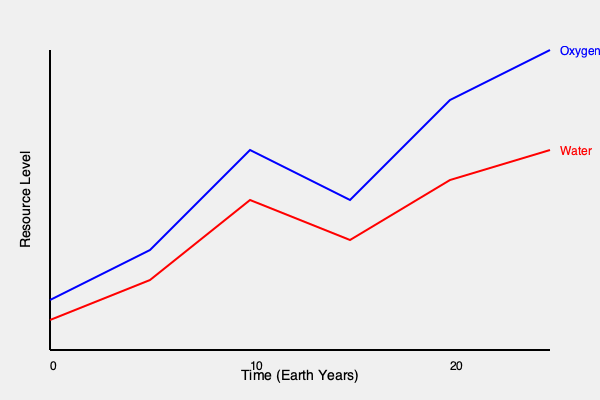In a futuristic space exploration mission, you're tasked with analyzing resource consumption trends. The graph shows oxygen and water levels over a 20-year period. What is the approximate ratio of the rate of oxygen depletion to water depletion between years 10 and 20? To solve this problem, we need to follow these steps:

1. Identify the data points for oxygen and water at years 10 and 20:
   - Year 10 (x-axis value 250): Oxygen ≈ 200, Water ≈ 240
   - Year 20 (x-axis value 550): Oxygen ≈ 50, Water ≈ 150

2. Calculate the change in levels for each resource:
   - Oxygen change: 200 - 50 = 150
   - Water change: 240 - 150 = 90

3. Calculate the rate of depletion for each resource:
   - Oxygen depletion rate = 150 / 10 years = 15 units/year
   - Water depletion rate = 90 / 10 years = 9 units/year

4. Calculate the ratio of oxygen depletion rate to water depletion rate:
   $\frac{\text{Oxygen depletion rate}}{\text{Water depletion rate}} = \frac{15}{9} = \frac{5}{3} \approx 1.67$

Therefore, the approximate ratio of the rate of oxygen depletion to water depletion between years 10 and 20 is 5:3 or about 1.67:1.
Answer: 5:3 or 1.67:1 